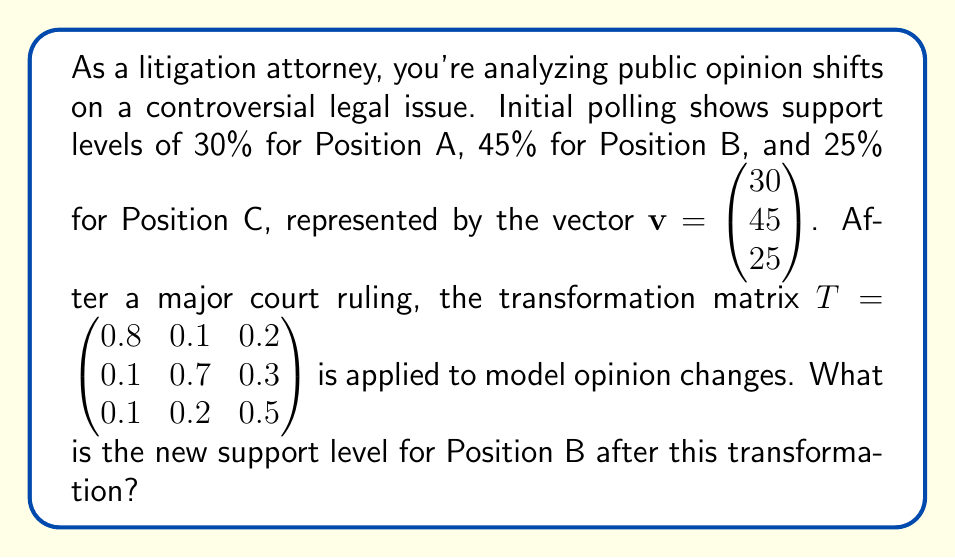What is the answer to this math problem? To solve this problem, we need to apply the linear transformation represented by matrix $T$ to the initial opinion vector $\mathbf{v}$. This is done by matrix multiplication:

1) First, let's set up the matrix multiplication:

   $T\mathbf{v} = \begin{pmatrix} 0.8 & 0.1 & 0.2 \\ 0.1 & 0.7 & 0.3 \\ 0.1 & 0.2 & 0.5 \end{pmatrix} \begin{pmatrix} 30 \\ 45 \\ 25 \end{pmatrix}$

2) Now, we perform the multiplication:

   $\begin{pmatrix} (0.8 \times 30) + (0.1 \times 45) + (0.2 \times 25) \\ (0.1 \times 30) + (0.7 \times 45) + (0.3 \times 25) \\ (0.1 \times 30) + (0.2 \times 45) + (0.5 \times 25) \end{pmatrix}$

3) Let's calculate each component:

   $\begin{pmatrix} 24 + 4.5 + 5 \\ 3 + 31.5 + 7.5 \\ 3 + 9 + 12.5 \end{pmatrix}$

4) Simplifying:

   $\begin{pmatrix} 33.5 \\ 42 \\ 24.5 \end{pmatrix}$

5) The new support levels are 33.5% for Position A, 42% for Position B, and 24.5% for Position C.

6) We're specifically asked about Position B, which is the second component of the resulting vector.

Therefore, the new support level for Position B is 42%.
Answer: 42% 